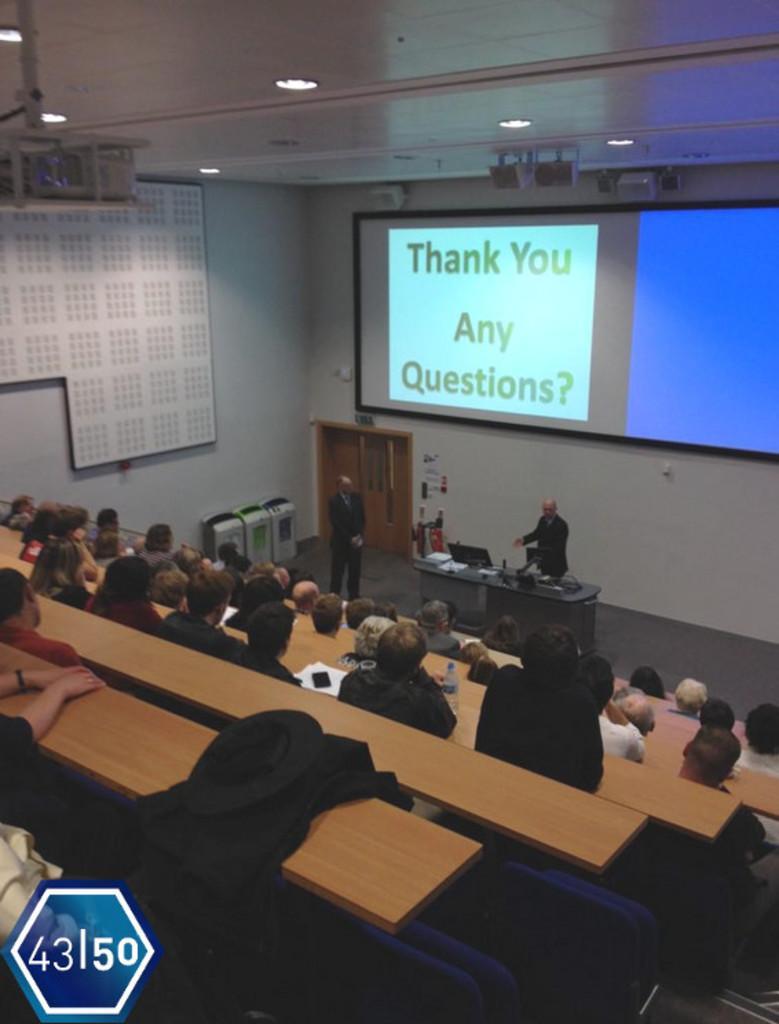Describe this image in one or two sentences. In this image we can see few persons are sitting at the tables and we can see a cloth, papers, water bottle and objects on the tables. In the background we can see a board, screen and objects on the walls, doors, two men are standing on the floor and there are objects on the table and on the floor. 